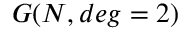<formula> <loc_0><loc_0><loc_500><loc_500>G ( N , d e g = 2 )</formula> 